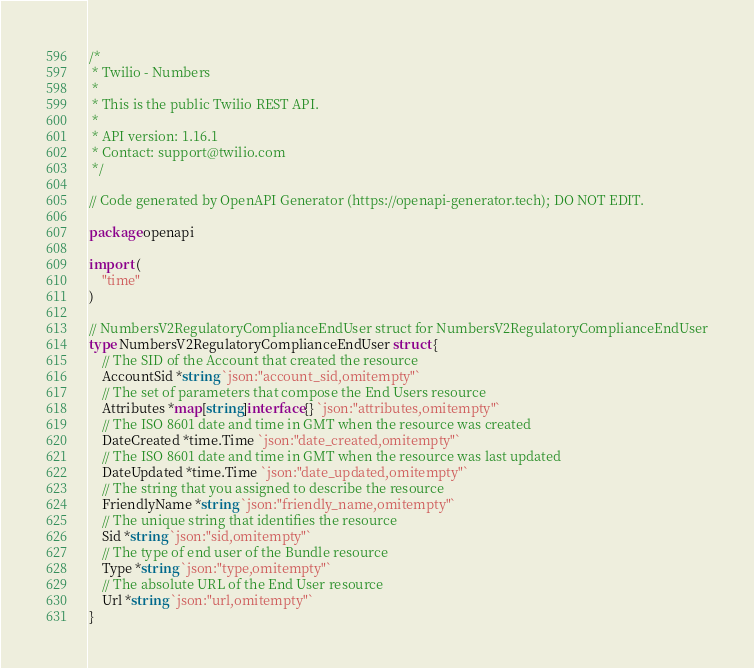<code> <loc_0><loc_0><loc_500><loc_500><_Go_>/*
 * Twilio - Numbers
 *
 * This is the public Twilio REST API.
 *
 * API version: 1.16.1
 * Contact: support@twilio.com
 */

// Code generated by OpenAPI Generator (https://openapi-generator.tech); DO NOT EDIT.

package openapi

import (
	"time"
)

// NumbersV2RegulatoryComplianceEndUser struct for NumbersV2RegulatoryComplianceEndUser
type NumbersV2RegulatoryComplianceEndUser struct {
	// The SID of the Account that created the resource
	AccountSid *string `json:"account_sid,omitempty"`
	// The set of parameters that compose the End Users resource
	Attributes *map[string]interface{} `json:"attributes,omitempty"`
	// The ISO 8601 date and time in GMT when the resource was created
	DateCreated *time.Time `json:"date_created,omitempty"`
	// The ISO 8601 date and time in GMT when the resource was last updated
	DateUpdated *time.Time `json:"date_updated,omitempty"`
	// The string that you assigned to describe the resource
	FriendlyName *string `json:"friendly_name,omitempty"`
	// The unique string that identifies the resource
	Sid *string `json:"sid,omitempty"`
	// The type of end user of the Bundle resource
	Type *string `json:"type,omitempty"`
	// The absolute URL of the End User resource
	Url *string `json:"url,omitempty"`
}
</code> 